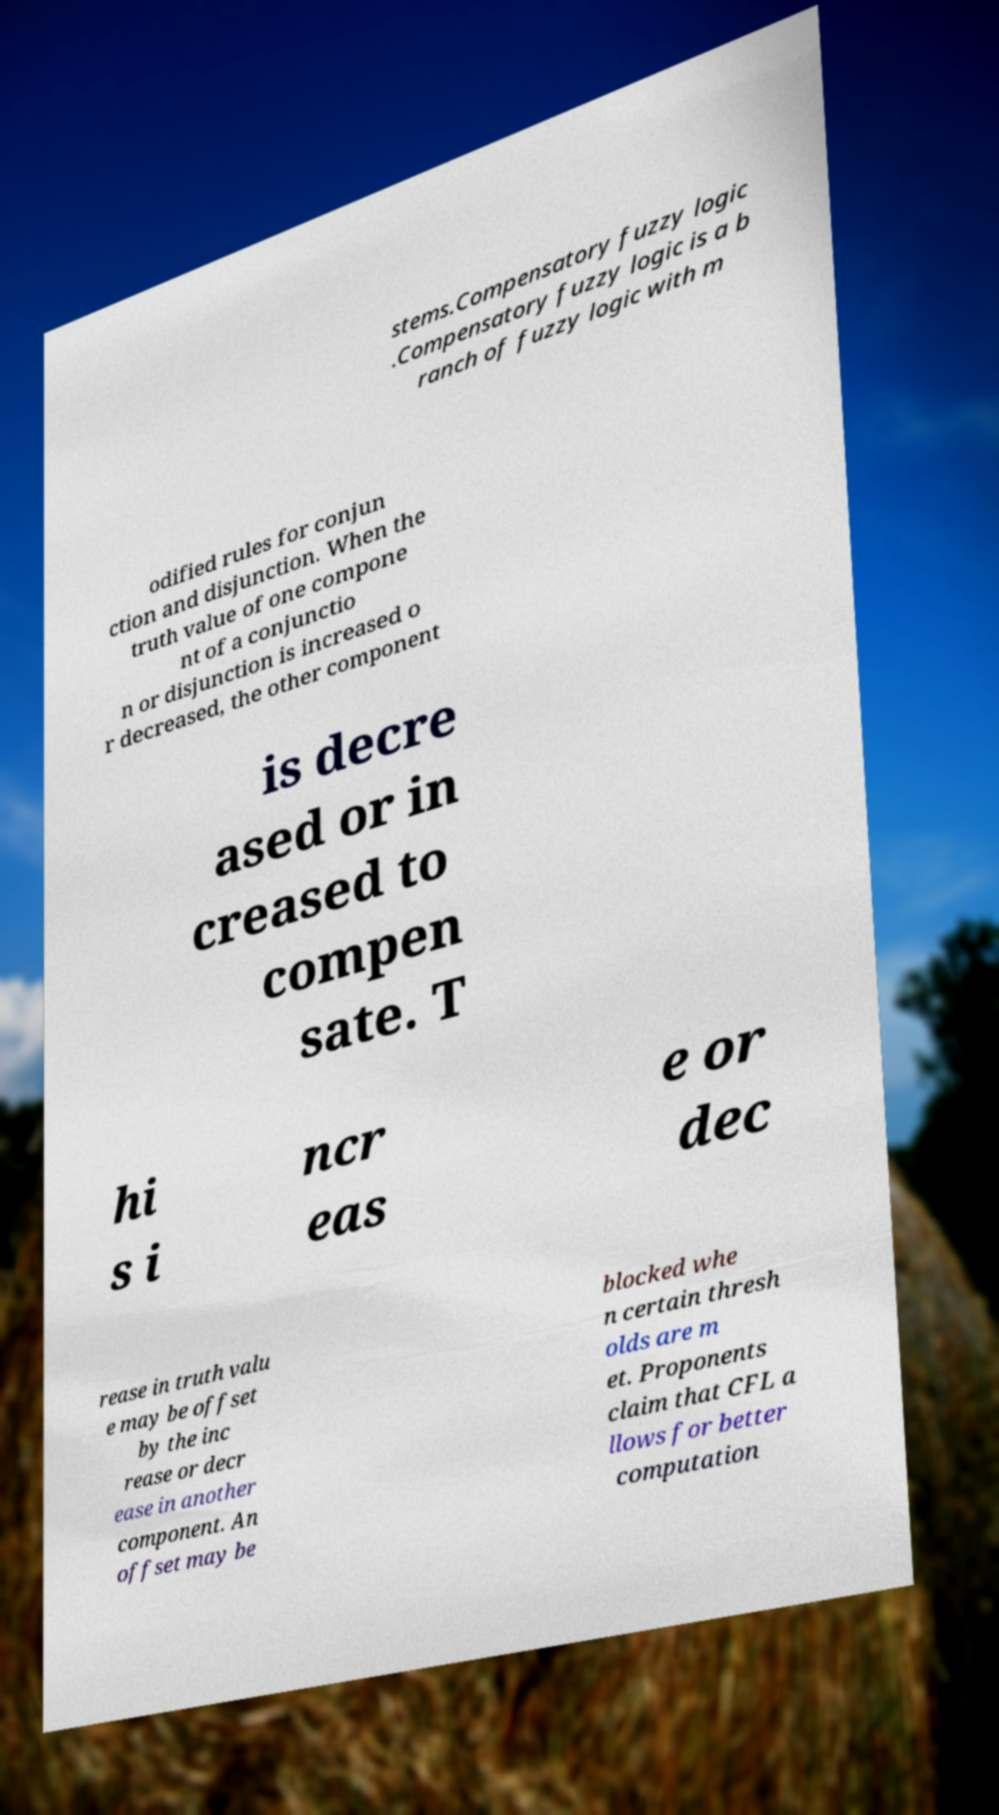Can you read and provide the text displayed in the image?This photo seems to have some interesting text. Can you extract and type it out for me? stems.Compensatory fuzzy logic .Compensatory fuzzy logic is a b ranch of fuzzy logic with m odified rules for conjun ction and disjunction. When the truth value of one compone nt of a conjunctio n or disjunction is increased o r decreased, the other component is decre ased or in creased to compen sate. T hi s i ncr eas e or dec rease in truth valu e may be offset by the inc rease or decr ease in another component. An offset may be blocked whe n certain thresh olds are m et. Proponents claim that CFL a llows for better computation 